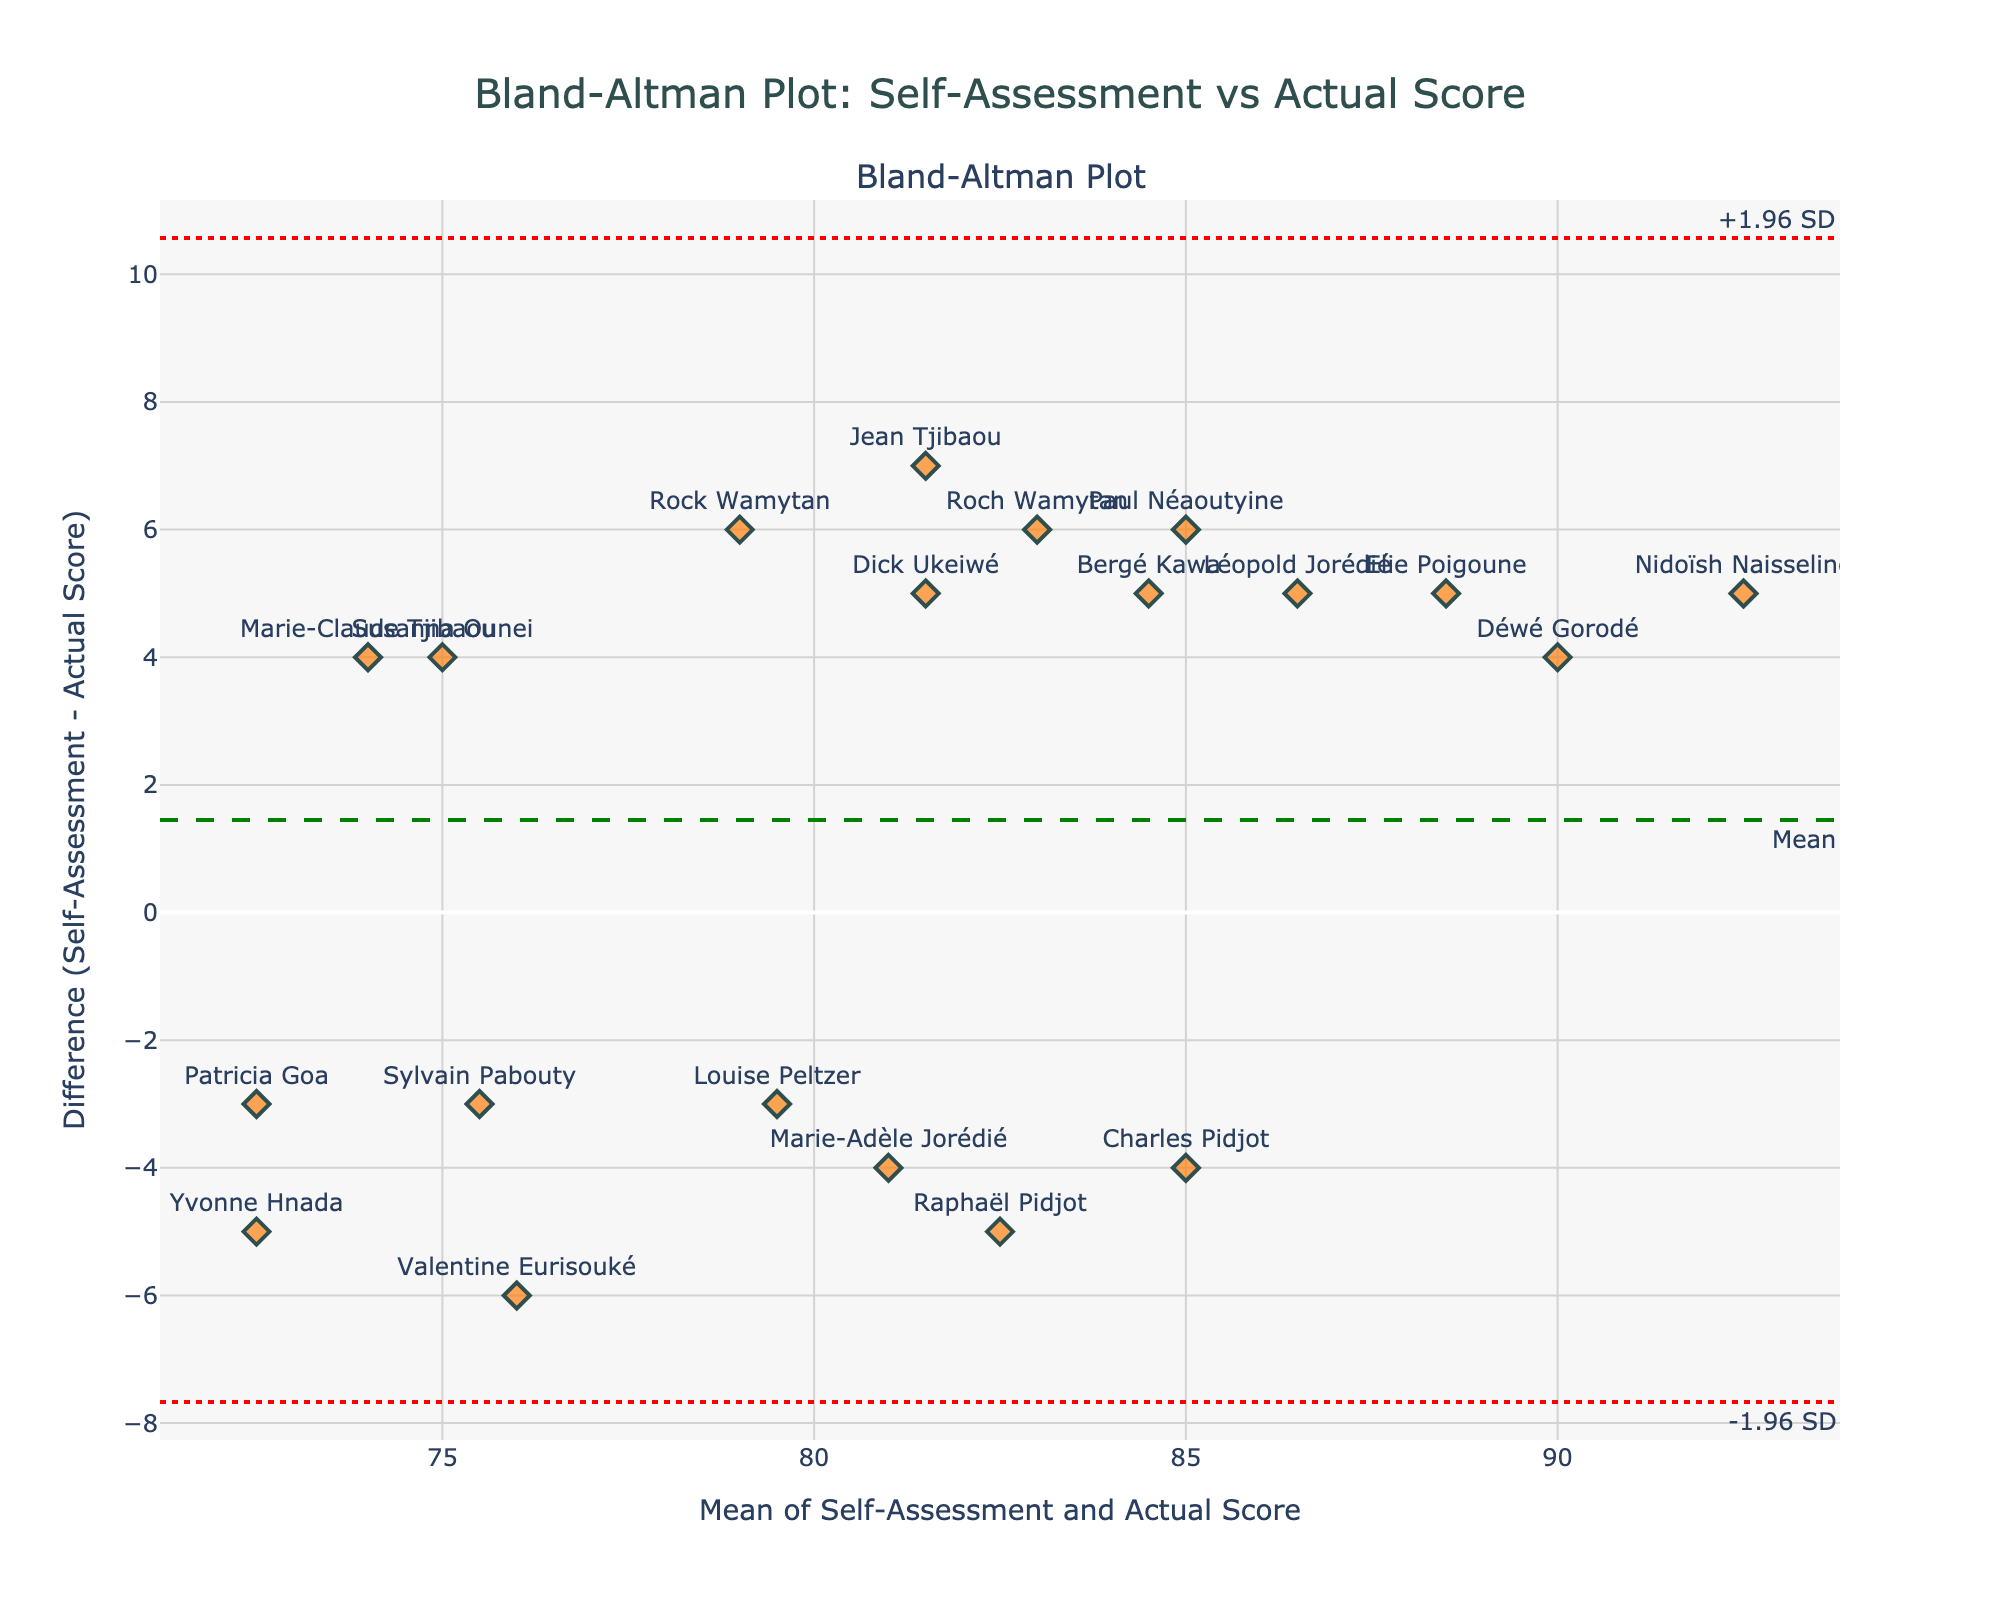how many students are shown on the plot? Count the number of data points (or markers) present in the plot.
Answer: 20 what is the mean difference line, and what does it signify? The mean difference line is marked with green color and labelled “Mean”. It signifies the average difference between self-assessed knowledge and actual scores, indicating the general trend of overestimation or underestimation.
Answer: The mean difference line is green; it shows the average difference between self-assessment and actual scores which student has the highest overestimation in self-assessment compared to their actual score? The student whose data point is the highest above the mean difference line (green line) has the highest positive difference.
Answer: Nidoïsh Naisseline which two students have almost equal self-assessment but different actual scores? Identify pairs of students where data points along the x-axis (mean of self-assessment and actual score) are close but differ significantly along the y-axis (difference).
Answer: Dick Ukeiwé and Roch Wamytan what is the range of the differences? The range is the absolute difference between the upper and lower limits of the agreement (red dotted lines).
Answer: 8.82 (4.34 to -4.48) where is the highest actual score compared to the self-assessment score? Search for the data point that is the lowest below the green line, indicating the actual score is higher than self-assessment.
Answer: Raphaël Pidjot are there more points above or below the mean difference line? Count the number of data points above and below the mean difference line (green line).
Answer: Above what does the spread of points around the mean difference line suggest? Analyze the scatter of the data points concerning the mean difference line and the limits of agreement.
Answer: The spread suggests variability in how students assess themselves compared to their actual scores what’s the difference for Déwé Gorodé and how does it compare to the mean difference? Locate Déwé Gorodé’s point on the y-axis and compare it to the mean difference line (green line).
Answer: +4 (above mean difference) what are the upper and lower limits of agreement, and what do they infer? The red dotted lines represent the different bounds calculated by adding and subtracting 1.96 times the standard deviation from the mean difference.
Answer: -4.48 to +4.34 (both differences indicate most self-assessment scores fall within this range from the actual scores) 